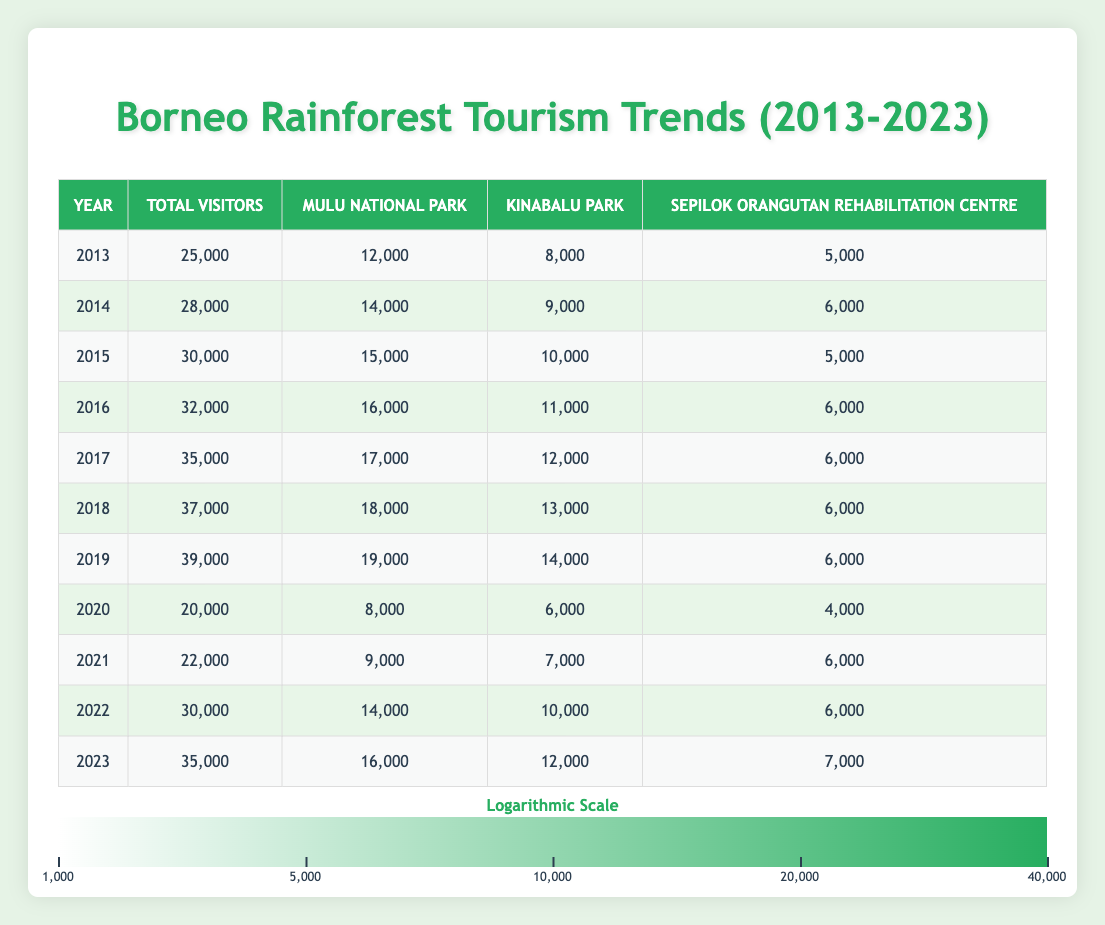What was the total number of visitors in 2015? The table shows a specific row for the year 2015, indicating that the total number of visitors that year was 30,000.
Answer: 30,000 In which year did the total number of visitors first exceed 35,000? By looking at the years in the table, the total number of visitors first exceeded 35,000 in 2017, when there were 35,000 visitors recorded.
Answer: 2017 What was the average number of visitors to Kinabalu Park over the last decade? To find the average for Kinabalu Park, we need to sum the visitors from each year (8000, 9000, 10000, 11000, 12000, 13000, 14000, 6000, 7000, 10000, 12000) which totals to 81,000. Then divide by the number of years (11), resulting in an average of 81,000 / 11 = 7,363.64.
Answer: 7,363.64 Did the number of visitors to Mulu National Park decrease between 2018 and 2020? In 2018, Mulu National Park had 18,000 visitors, and in 2020, it dropped to 8,000 visitors. Since 8,000 is less than 18,000, it confirms that there was a decrease.
Answer: Yes How many total visitors did Sepilok Orangutan Rehabilitation Centre have in the year of the highest overall visitor count? The highest overall visitor count was in 2019 with 39,000 visitors. In that year, the Sepilok Orangutan Rehabilitation Centre had 6,000 visitors, which is provided in the corresponding row.
Answer: 6,000 What was the percentage increase in total visitors from 2013 to 2019? To calculate the percentage increase, we take the difference between the visitors in 2019 (39,000) and 2013 (25,000), which is 14,000. Then, divide this difference by the number of visitors in 2013 (25,000): (14,000 / 25,000) * 100 = 56%.
Answer: 56% Which year had the least number of visitors and how many were recorded? By analyzing the table, we find that 2020 had the least number of visitors with a total of 20,000.
Answer: 20,000 Was there an overall increase in visitors from 2021 to 2022? In 2021, there were 22,000 visitors, and in 2022, it increased to 30,000 visitors. Since 30,000 is greater than 22,000, it indicates an overall increase.
Answer: Yes 